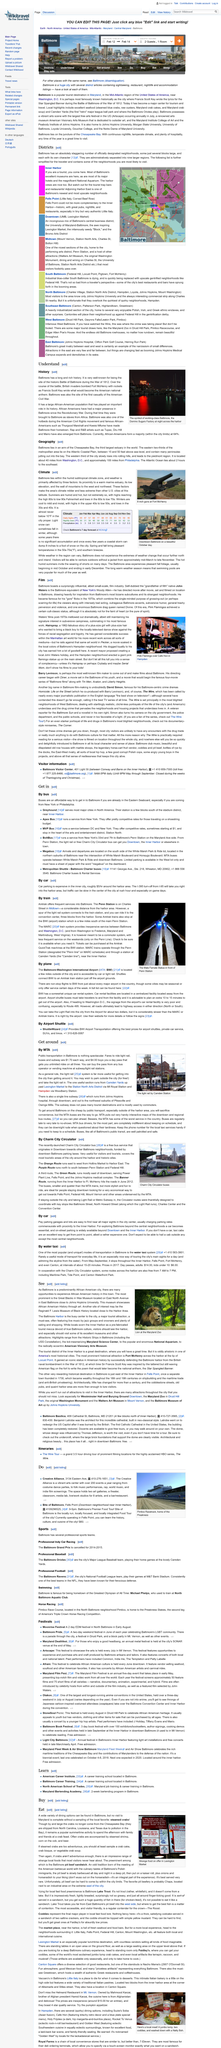Give some essential details in this illustration. The Hampden neighborhood erected the statue that is shown in the photo. In Baltimore, 64% of the population is African-American. Mahmood Karzai is the owner of the Helmand Restaurant in Mt. Vernon. Chesapeake Bay is the third largest estuary in the world. It is known for its vast expanse and rich biodiversity. The drink shown in the picture is called National and is abbreviated to Natty in the description. 